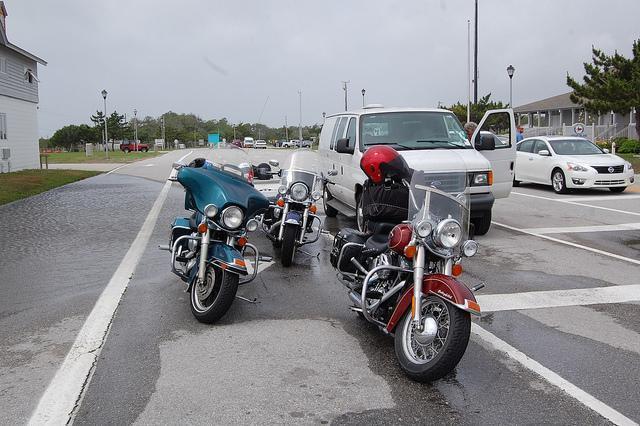Where are these vehicles located?
From the following four choices, select the correct answer to address the question.
Options: Parking lot, garage, highway, driveway. Parking lot. 